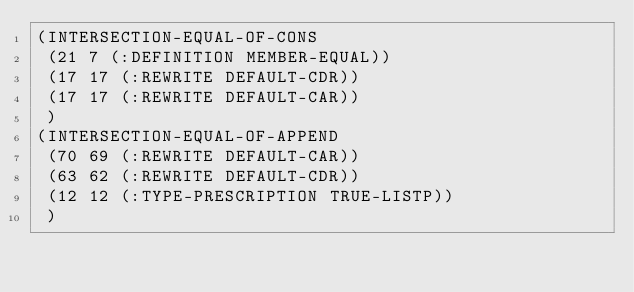Convert code to text. <code><loc_0><loc_0><loc_500><loc_500><_Lisp_>(INTERSECTION-EQUAL-OF-CONS
 (21 7 (:DEFINITION MEMBER-EQUAL))
 (17 17 (:REWRITE DEFAULT-CDR))
 (17 17 (:REWRITE DEFAULT-CAR))
 )
(INTERSECTION-EQUAL-OF-APPEND
 (70 69 (:REWRITE DEFAULT-CAR))
 (63 62 (:REWRITE DEFAULT-CDR))
 (12 12 (:TYPE-PRESCRIPTION TRUE-LISTP))
 )</code> 